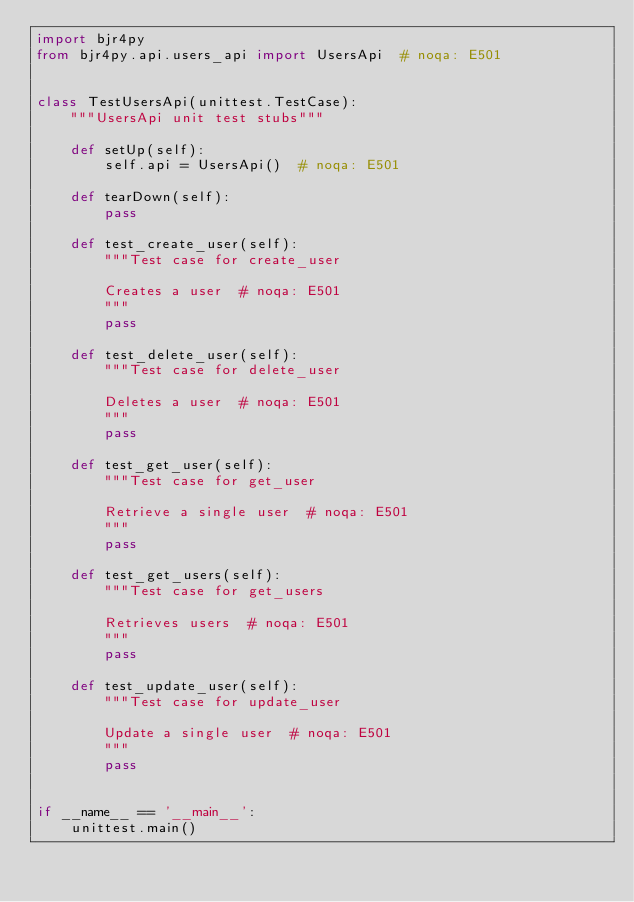<code> <loc_0><loc_0><loc_500><loc_500><_Python_>import bjr4py
from bjr4py.api.users_api import UsersApi  # noqa: E501


class TestUsersApi(unittest.TestCase):
    """UsersApi unit test stubs"""

    def setUp(self):
        self.api = UsersApi()  # noqa: E501

    def tearDown(self):
        pass

    def test_create_user(self):
        """Test case for create_user

        Creates a user  # noqa: E501
        """
        pass

    def test_delete_user(self):
        """Test case for delete_user

        Deletes a user  # noqa: E501
        """
        pass

    def test_get_user(self):
        """Test case for get_user

        Retrieve a single user  # noqa: E501
        """
        pass

    def test_get_users(self):
        """Test case for get_users

        Retrieves users  # noqa: E501
        """
        pass

    def test_update_user(self):
        """Test case for update_user

        Update a single user  # noqa: E501
        """
        pass


if __name__ == '__main__':
    unittest.main()
</code> 